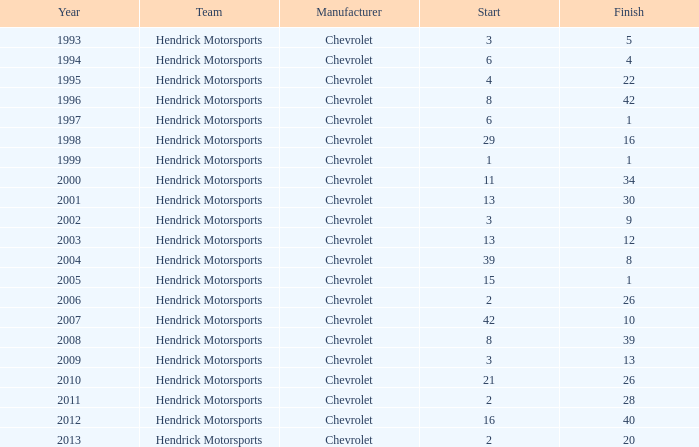Which team had a start of 8 in years under 2008? Hendrick Motorsports. 